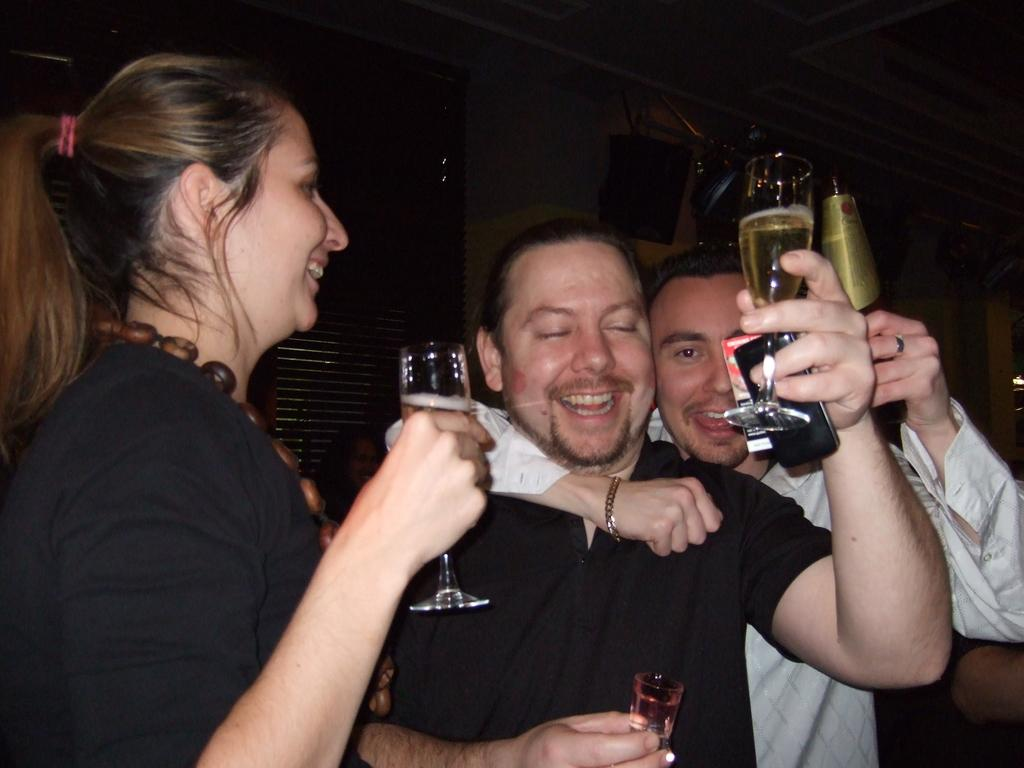Who or what is present in the image? There are people in the image. What are the people holding in their hands? The people are holding wine glasses. What is the facial expression of the people in the image? The people are smiling. What can be seen in the background of the image? There is a wall in the background of the image. What type of door is visible beside the wall? There is a wooden door beside the wall. What type of scent can be detected from the wine glasses in the image? There is no information about the scent of the wine in the image, and therefore it cannot be determined. 